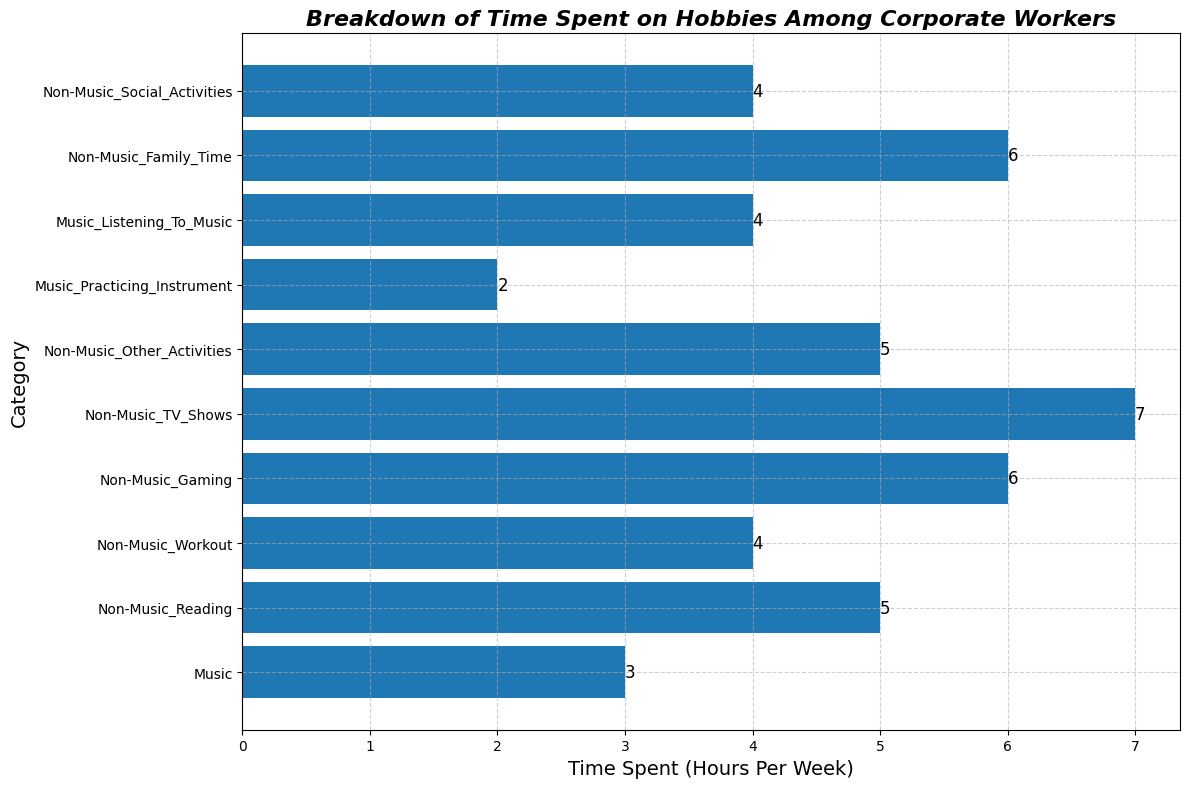What's the total time spent on music-related activities? There are two music-related categories: "Music_Practicing_Instrument" (2 hours) and "Music_Listening_To_Music" (4 hours). Summing these gives 2 + 4 = 6 hours.
Answer: 6 hours Which category has the highest time spent? Looking at the bar lengths, "Non-Music_TV_Shows" has the longest bar, which indicates the highest time spent of 7 hours.
Answer: Non-Music_TV_Shows How much more time is spent on "Non-Music_Gaming" than on "Music"? The bar for "Non-Music_Gaming" shows 6 hours, and the bar for "Music" shows 3 hours. The difference is 6 - 3 = 3 hours.
Answer: 3 hours What is the average time spent on non-music activities? The non-music activities and their respective times are: Reading (5), Workout (4), Gaming (6), TV Shows (7), Other Activities (5), Family Time (6), Social Activities (4). Sum these: 5 + 4 + 6 + 7 + 5 + 6 + 4 = 37 hours. The average is 37/7 = 5.29 hours (rounded to 2 decimal places).
Answer: 5.29 hours How does the time spent on "Music_Listening_To_Music" compare to "Non-Music_Workout"? The bar for "Music_Listening_To_Music" shows 4 hours, while "Non-Music_Workout" shows 4 hours as well. They are equal.
Answer: Equal Which category has the least time spent? The shortest bar corresponds to "Music_Practicing_Instrument" with 2 hours.
Answer: Music_Practicing_Instrument What is the combined time spent on "Non-Music_Family_Time" and "Non-Music_Social_Activities"? "Non-Music_Family_Time" is 6 hours and "Non-Music_Social_Activities" is 4 hours. Summing these gives 6 + 4 = 10 hours.
Answer: 10 hours What's the difference in time spent on "Non-Music_TV_Shows" and "Non-Music_Reading"? "Non-Music_TV_Shows" is 7 hours and "Non-Music_Reading" is 5 hours. The difference is 7 - 5 = 2 hours.
Answer: 2 hours Does "Non-Music_Gaming" and "Non-Music_Family_Time" together exceed the total time spent on music-related activities? "Non-Music_Gaming" is 6 hours and "Non-Music_Family_Time" is 6 hours. Together, they total 12 hours (6 + 6). The total time for music-related activities is 6 hours. Thus, 12 hours > 6 hours.
Answer: Yes What is the time range (difference between the highest and lowest times) for all categories? The highest time spent is on "Non-Music_TV_Shows" with 7 hours, and the lowest is on "Music_Practicing_Instrument" with 2 hours. The range is 7 - 2 = 5 hours.
Answer: 5 hours 